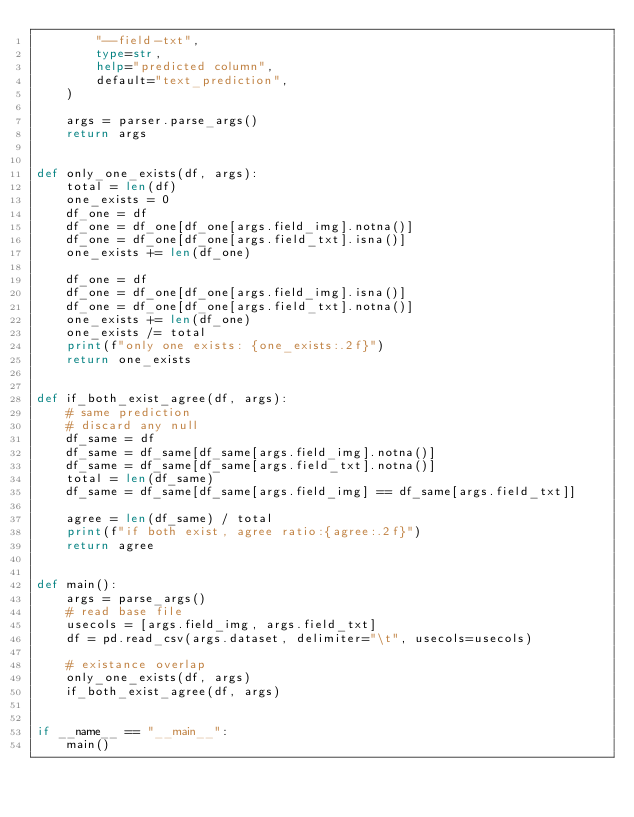<code> <loc_0><loc_0><loc_500><loc_500><_Python_>        "--field-txt",
        type=str,
        help="predicted column",
        default="text_prediction",
    )

    args = parser.parse_args()
    return args


def only_one_exists(df, args):
    total = len(df)
    one_exists = 0
    df_one = df
    df_one = df_one[df_one[args.field_img].notna()]
    df_one = df_one[df_one[args.field_txt].isna()]
    one_exists += len(df_one)

    df_one = df
    df_one = df_one[df_one[args.field_img].isna()]
    df_one = df_one[df_one[args.field_txt].notna()]
    one_exists += len(df_one)
    one_exists /= total
    print(f"only one exists: {one_exists:.2f}")
    return one_exists


def if_both_exist_agree(df, args):
    # same prediction
    # discard any null
    df_same = df
    df_same = df_same[df_same[args.field_img].notna()]
    df_same = df_same[df_same[args.field_txt].notna()]
    total = len(df_same)
    df_same = df_same[df_same[args.field_img] == df_same[args.field_txt]]

    agree = len(df_same) / total
    print(f"if both exist, agree ratio:{agree:.2f}")
    return agree


def main():
    args = parse_args()
    # read base file
    usecols = [args.field_img, args.field_txt]
    df = pd.read_csv(args.dataset, delimiter="\t", usecols=usecols)

    # existance overlap
    only_one_exists(df, args)
    if_both_exist_agree(df, args)


if __name__ == "__main__":
    main()
</code> 